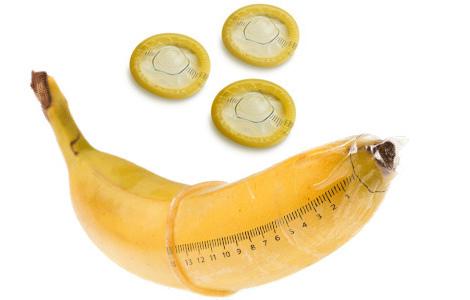Which fruit is this?
Keep it brief. Banana. Is this plastic item waterproof?
Give a very brief answer. Yes. What would be measured by the lines on the plastic item?
Concise answer only. Length. 